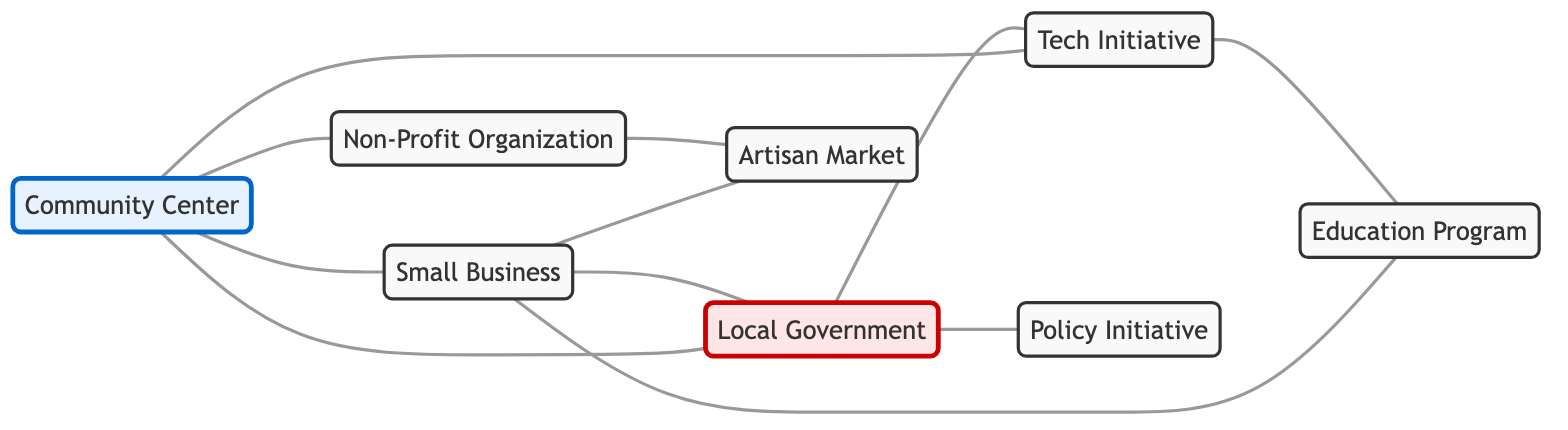What is the total number of nodes in the diagram? To find the total number of nodes, we can count all unique entities in the diagram. The nodes are: Community Center, Small Business, Local Government, Tech Initiative, Non-Profit Organization, Artisan Market, Education Program, and Policy Initiative. Counting these gives us a total of 8 nodes.
Answer: 8 Which node connects directly to the Non-Profit Organization? To determine which node connects directly to the Non-Profit Organization, we refer to the connections listed. The direct connections for Non-Profit Organization are Artisan Market and Community Center. Therefore, the direct connection in this context is Artisan Market.
Answer: Artisan Market How many connections does the Local Government have? We need to look at the connections listed for Local Government. It connects to the Community Center, Small Business, Tech Initiative, and Policy Initiative. Counting these connections gives us a total of 4 connections.
Answer: 4 Which two nodes are connected to both the Small Business and the Community Center? We will analyze the connections of both Small Business and Community Center. Small Business connects to Community Center, Local Government, Artisan Market, and Education Program. Community Center connects to Local Government, Tech Initiative, Non-Profit Organization, and Small Business. The common nodes both connect to are Local Government.
Answer: Local Government Which organization has the fewest connections? By examining the connection counts, we find the following: Community Center (4), Small Business (4), Local Government (4), Tech Initiative (3), Non-Profit Organization (2), Artisan Market (2), Education Program (2), and Policy Initiative (1). The organization with the fewest connections is Policy Initiative.
Answer: Policy Initiative What are the two unique entities directly connected to the Tech Initiative? We look at the connections listed for Tech Initiative. It connects directly to Community Center, Local Government, and Education Program. Based on this, the unique entities are Community Center and Education Program.
Answer: Community Center, Education Program How many unique relationships involve the Small Business? We examine the connections involving Small Business: it connects with Community Center, Local Government, Education Program, and Artisan Market. Counting these different relationships, we find there are 4 unique relationships involving Small Business.
Answer: 4 Which initiative has a direct connection to the Local Government but not to the Non-Profit Organization? Reviewing the connections for Local Government, we see it connects to Community Center, Small Business, Tech Initiative, and Policy Initiative. Non-Profit Organization connects to Community Center and Artisan Market. The initiatives that connect directly to Local Government but not to Non-Profit Organization are Small Business, Tech Initiative, and Policy Initiative. Therefore, one clear initiative is Small Business.
Answer: Small Business 